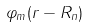Convert formula to latex. <formula><loc_0><loc_0><loc_500><loc_500>\varphi _ { m } ( r - R _ { n } )</formula> 